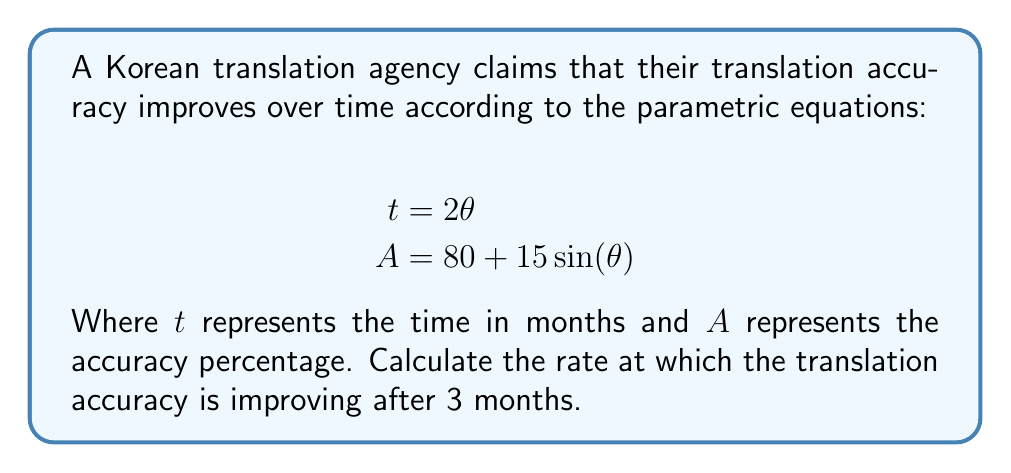Solve this math problem. To solve this problem, we need to follow these steps:

1) First, we need to find $\theta$ when $t = 3$ months:
   $$t = 2\theta$$
   $$3 = 2\theta$$
   $$\theta = \frac{3}{2} = 1.5$$

2) Now, we need to find the rate of change of accuracy with respect to time. This is given by:
   $$\frac{dA}{dt} = \frac{dA}{d\theta} \cdot \frac{d\theta}{dt}$$

3) From the equation for $t$, we can find $\frac{d\theta}{dt}$:
   $$t = 2\theta$$
   $$\frac{dt}{d\theta} = 2$$
   $$\frac{d\theta}{dt} = \frac{1}{2}$$

4) Now, let's find $\frac{dA}{d\theta}$:
   $$A = 80 + 15\sin(\theta)$$
   $$\frac{dA}{d\theta} = 15\cos(\theta)$$

5) Substituting these into our rate of change equation:
   $$\frac{dA}{dt} = 15\cos(\theta) \cdot \frac{1}{2} = \frac{15}{2}\cos(\theta)$$

6) Now, we can evaluate this at $\theta = 1.5$:
   $$\frac{dA}{dt} = \frac{15}{2}\cos(1.5)$$

7) Using a calculator or computer to evaluate $\cos(1.5)$:
   $$\frac{dA}{dt} = \frac{15}{2} \cdot 0.0707 \approx 0.53$$
Answer: The rate at which the translation accuracy is improving after 3 months is approximately 0.53% per month. 